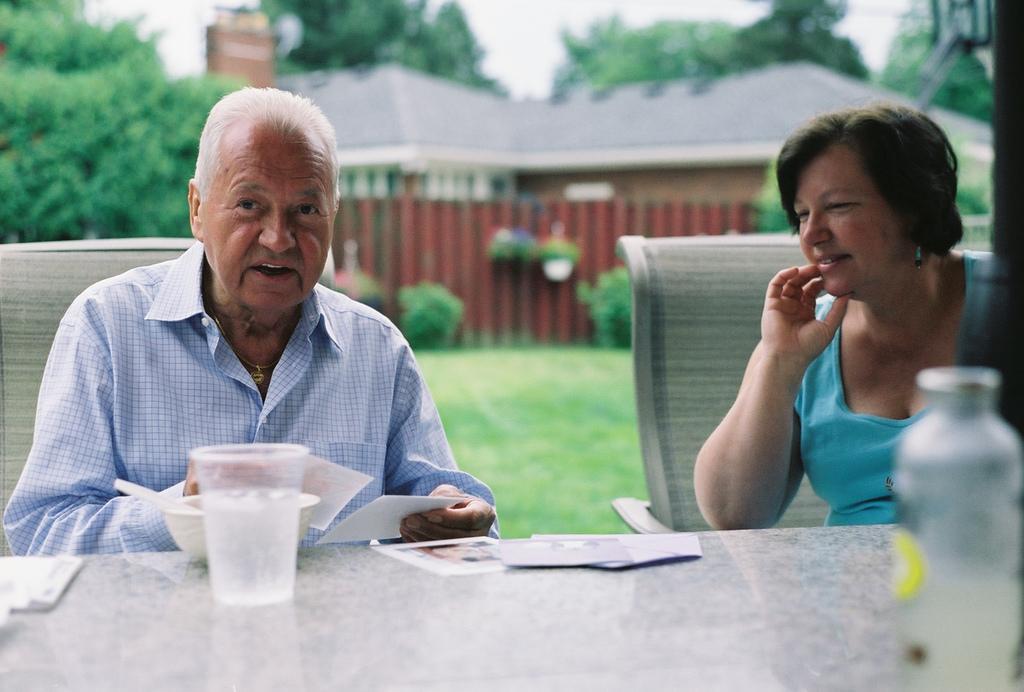Can you describe this image briefly? This is a picture of a man sitting in the chair , woman sitting in the chair and in table we have glass , bowl,spoon,papers,and a bottle and at the back ground we have house ,plants ,grass,sky,tree. 